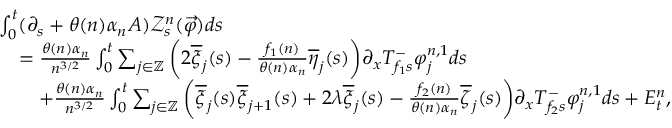Convert formula to latex. <formula><loc_0><loc_0><loc_500><loc_500>\begin{array} { r l } & { \int _ { 0 } ^ { t } ( \partial _ { s } + \theta ( n ) \alpha _ { n } A ) \mathcal { Z } _ { s } ^ { n } ( \overrightarrow { \varphi } ) d s } \\ & { \quad = \frac { \theta ( n ) \alpha _ { n } } { n ^ { 3 / 2 } } \int _ { 0 } ^ { t } \sum _ { j \in \mathbb { Z } } \left ( 2 \overline { \xi } _ { j } ( s ) - \frac { f _ { 1 } ( n ) } { \theta ( n ) \alpha _ { n } } \overline { \eta } _ { j } ( s ) \right ) \partial _ { x } T _ { f _ { 1 } s } ^ { - } \varphi _ { j } ^ { n , 1 } d s } \\ & { \quad + \frac { \theta ( n ) \alpha _ { n } } { n ^ { 3 / 2 } } \int _ { 0 } ^ { t } \sum _ { j \in \mathbb { Z } } \left ( \overline { \xi } _ { j } ( s ) \overline { \xi } _ { j + 1 } ( s ) + 2 \lambda \overline { \xi } _ { j } ( s ) - \frac { f _ { 2 } ( n ) } { \theta ( n ) \alpha _ { n } } \overline { \zeta } _ { j } ( s ) \right ) \partial _ { x } T _ { f _ { 2 } s } ^ { - } \varphi _ { j } ^ { n , 1 } d s + E _ { t } ^ { n } , } \end{array}</formula> 